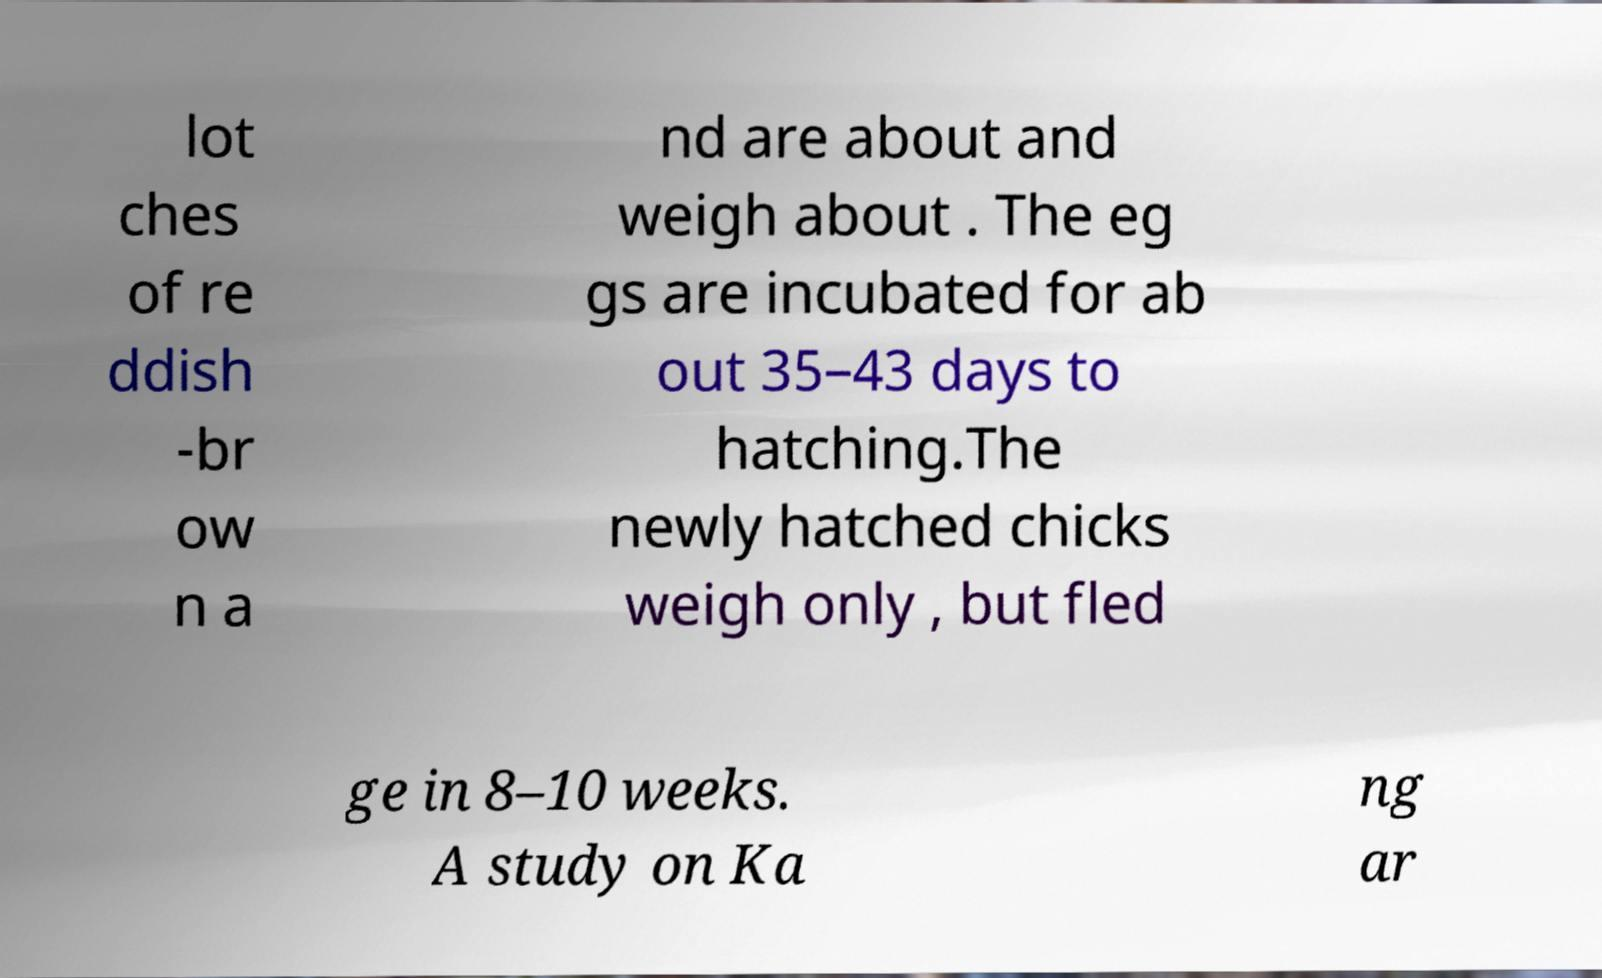I need the written content from this picture converted into text. Can you do that? lot ches of re ddish -br ow n a nd are about and weigh about . The eg gs are incubated for ab out 35–43 days to hatching.The newly hatched chicks weigh only , but fled ge in 8–10 weeks. A study on Ka ng ar 